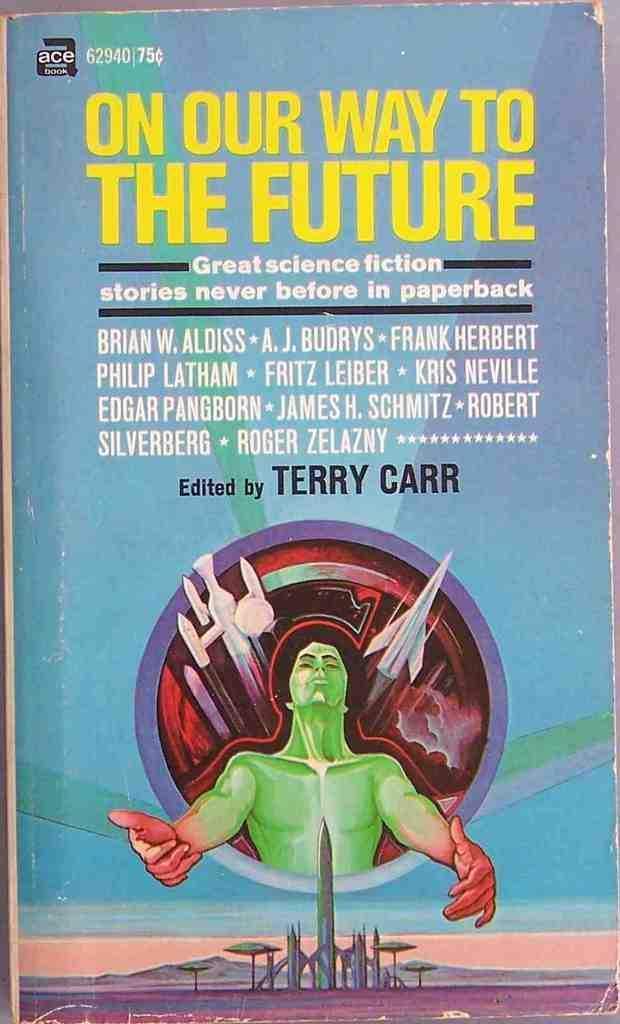Please provide a concise description of this image. In the image we can see there is a cover page of the book on which there is a drawing of a man and there are buildings and rockets. The matter is written on it is "On The Way To The Future". 